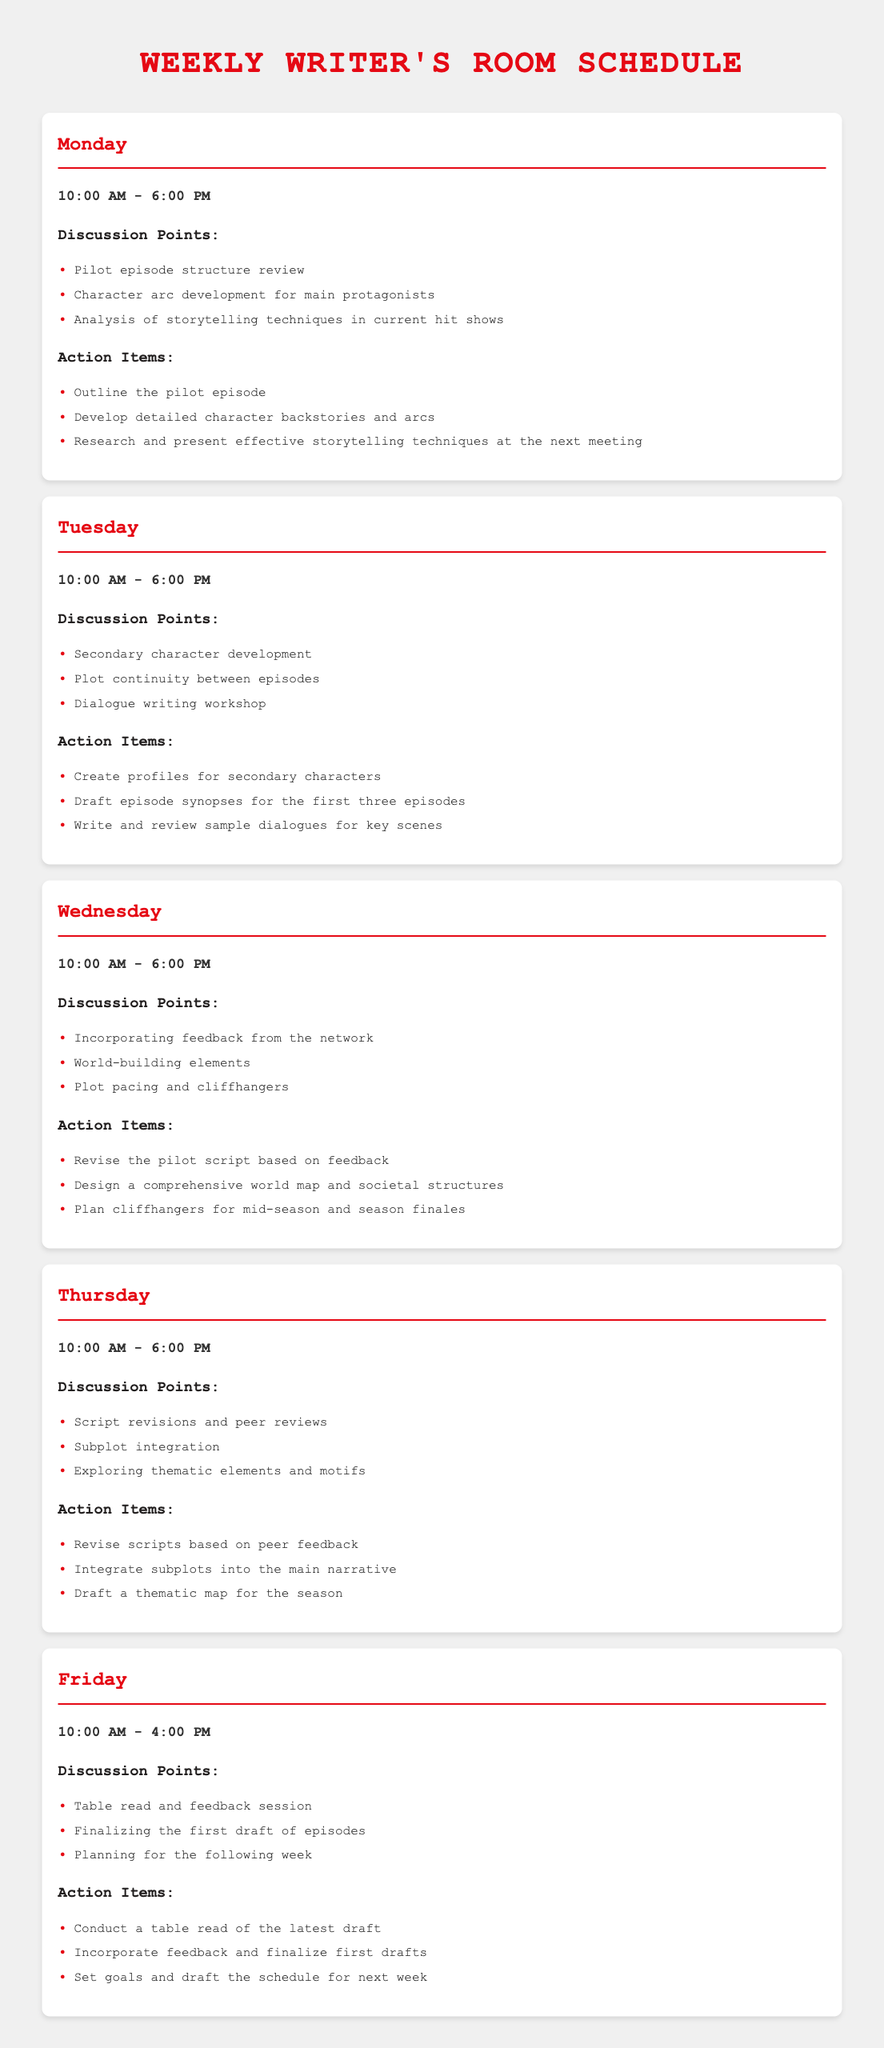what are the discussion points for Monday? The discussion points for Monday include Pilot episode structure review, Character arc development for main protagonists, and Analysis of storytelling techniques in current hit shows.
Answer: Pilot episode structure review, Character arc development for main protagonists, Analysis of storytelling techniques in current hit shows how long is the Friday session? The Friday session runs from 10:00 AM to 4:00 PM, which is a total of 6 hours.
Answer: 6 hours what is the first action item on Tuesday? The first action item on Tuesday is to create profiles for secondary characters.
Answer: Create profiles for secondary characters which day focuses on script revisions and peer reviews? The day that focuses on script revisions and peer reviews is Thursday.
Answer: Thursday how many hours does the writer’s room meet on Wednesday? The writer's room meets for 8 hours on Wednesday, from 10:00 AM to 6:00 PM.
Answer: 8 hours what action should be taken after the table read on Friday? After the table read on Friday, the action is to incorporate feedback and finalize first drafts.
Answer: Incorporate feedback and finalize first drafts what is one of the discussion points for Thursday? One of the discussion points for Thursday is subplot integration.
Answer: Subplot integration what is the objective of the Monday session? The objective of the Monday session includes reviewing the pilot episode structure and character arcs.
Answer: Reviewing the pilot episode structure and character arcs 